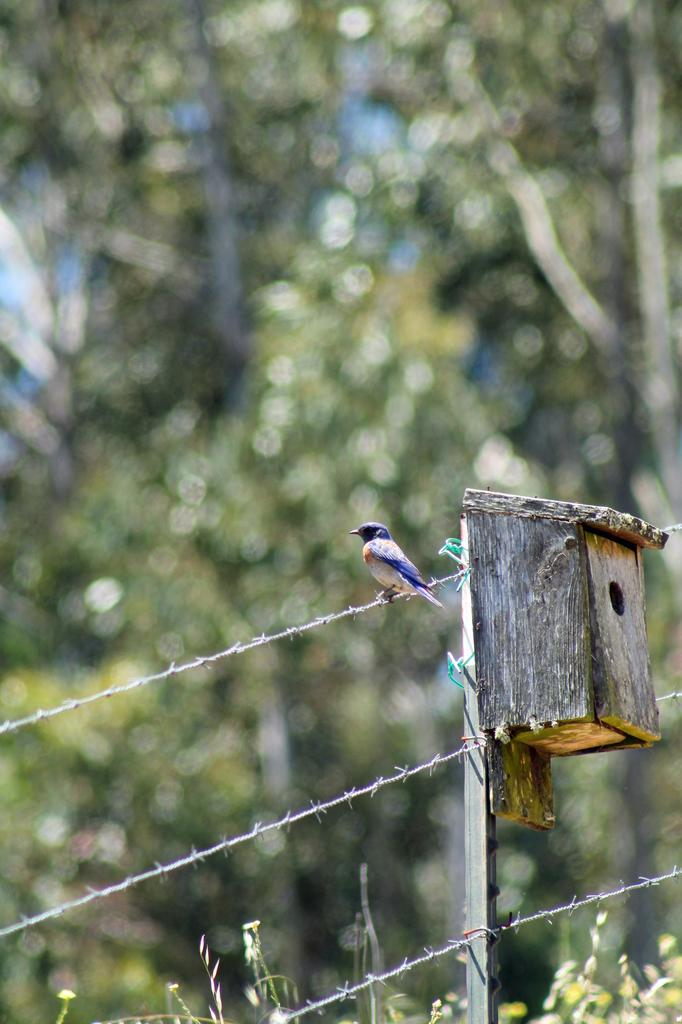What type of animal can be seen in the image? There is a bird in the image. Where is the bird located? The bird is standing on a fence. What is visible behind the bird? There is a wooden box behind the bird. What can be seen in the background of the image? There are trees in the background of the image. Can you see any crayons being used by the bird in the image? There are no crayons present in the image, and the bird is not using any. 